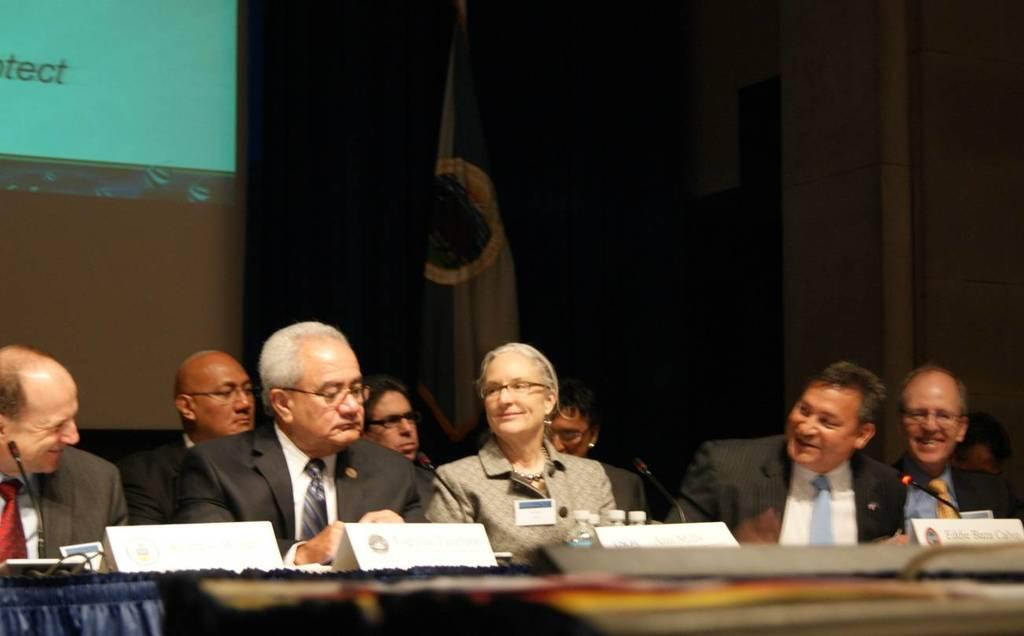What are the people in the image doing? The people are sitting in the center of the image. What is in front of the people? They are in front of a desk. What can be seen in the background of the image? There is a flag and a screen in the background of the image. What type of shame can be seen on the people's faces in the image? There is no indication of shame on the people's faces in the image. How many wings are visible on the people in the image? The people in the image do not have wings, as they are not depicted as angels or any other winged creatures. 